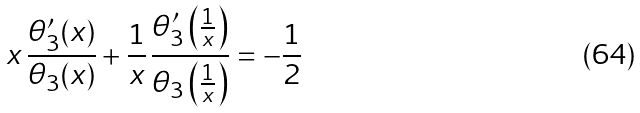Convert formula to latex. <formula><loc_0><loc_0><loc_500><loc_500>x \, \frac { \theta _ { 3 } ^ { \prime } ( x ) } { \theta _ { 3 } ( x ) } + \frac { 1 } { x } \, \frac { \theta _ { 3 } ^ { \prime } \left ( \frac { 1 } { x } \right ) } { \theta _ { 3 } \left ( \frac { 1 } { x } \right ) } = - \frac { 1 } { 2 }</formula> 